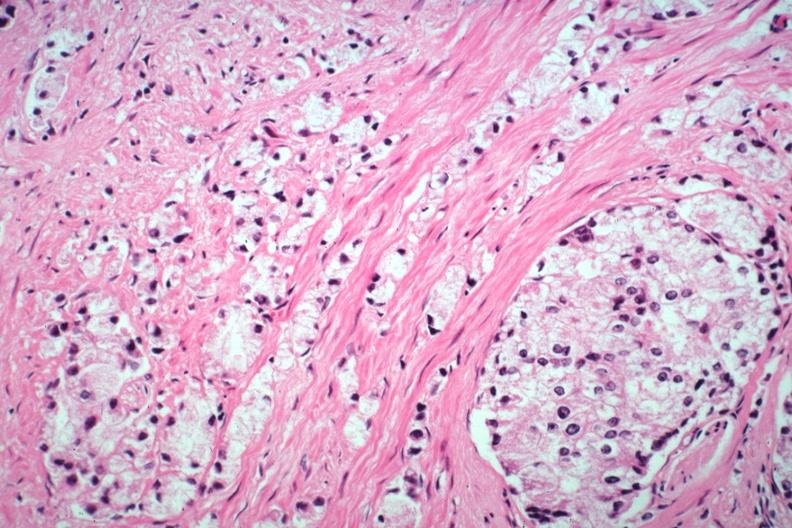s adenocarcinoma present?
Answer the question using a single word or phrase. Yes 